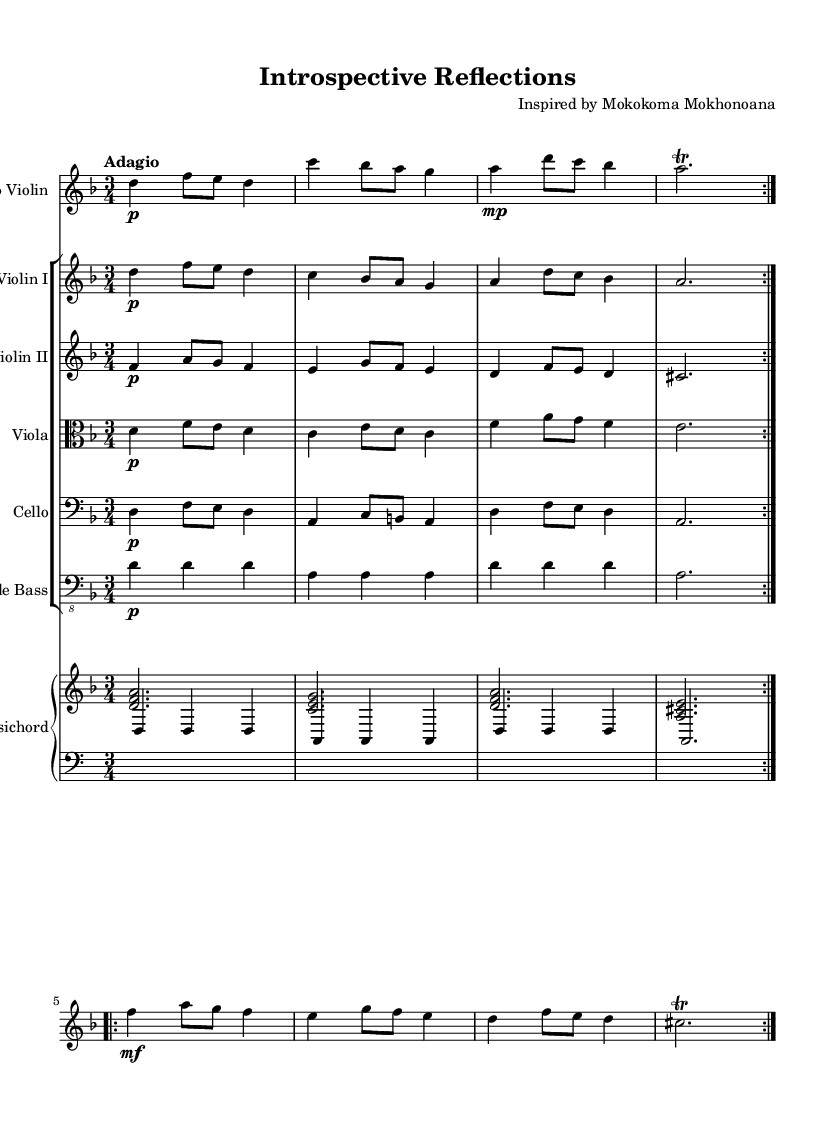What is the key signature of this piece? The key signature is indicated at the beginning of the staff; it shows one flat, indicating D minor.
Answer: D minor What is the time signature of this music? The time signature is located at the beginning of the score next to the key signature and is 3/4, indicating three beats per measure.
Answer: 3/4 What is the tempo marking for this composition? The tempo marking appears above the staff and is labeled "Adagio," which denotes a slow and leisurely pace.
Answer: Adagio How many times does the solo violin part repeat its section in the first volta? The solo violin part has a repeat symbol indicating it is played two times in the first volta.
Answer: 2 Which instrument plays the harmonic role alongside the string ensemble? The instrument responsible for providing harmonic and rhythmic support is indicated as "Harpsichord" in the score, positioned underneath the strings.
Answer: Harpsichord In which section of the ensemble does the viola part appear? The viola is represented in the score with a clef difference, specifically the alto clef, which is traditional for viola parts, placed among the string sections.
Answer: Viola 